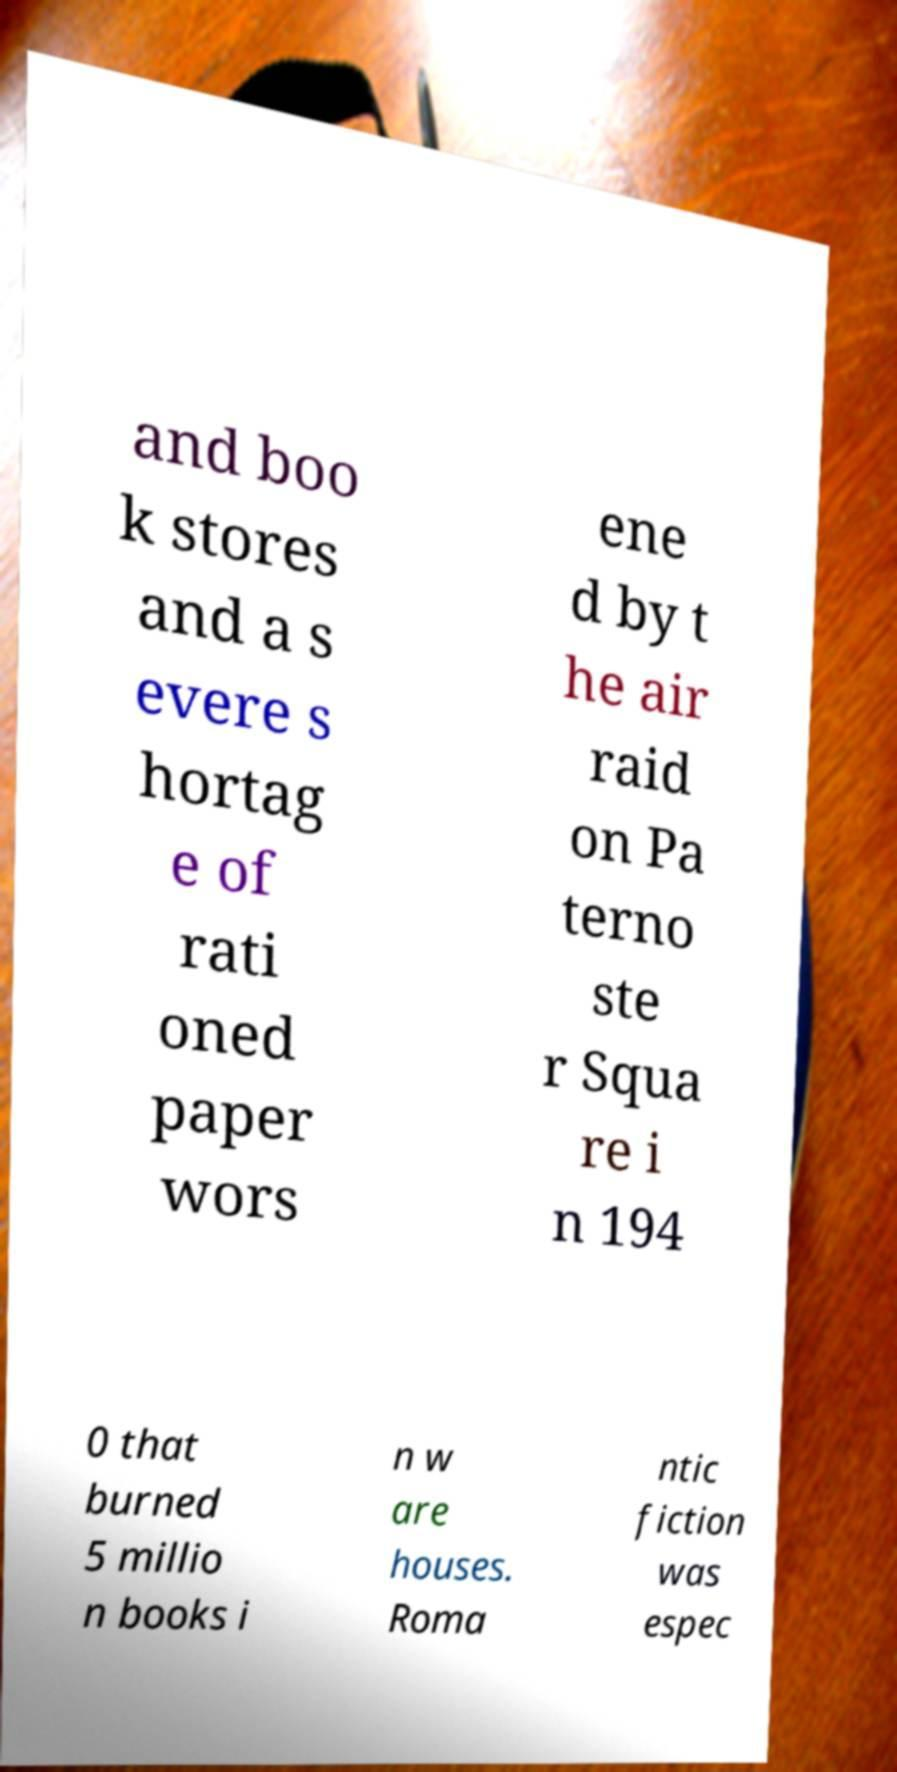What messages or text are displayed in this image? I need them in a readable, typed format. and boo k stores and a s evere s hortag e of rati oned paper wors ene d by t he air raid on Pa terno ste r Squa re i n 194 0 that burned 5 millio n books i n w are houses. Roma ntic fiction was espec 